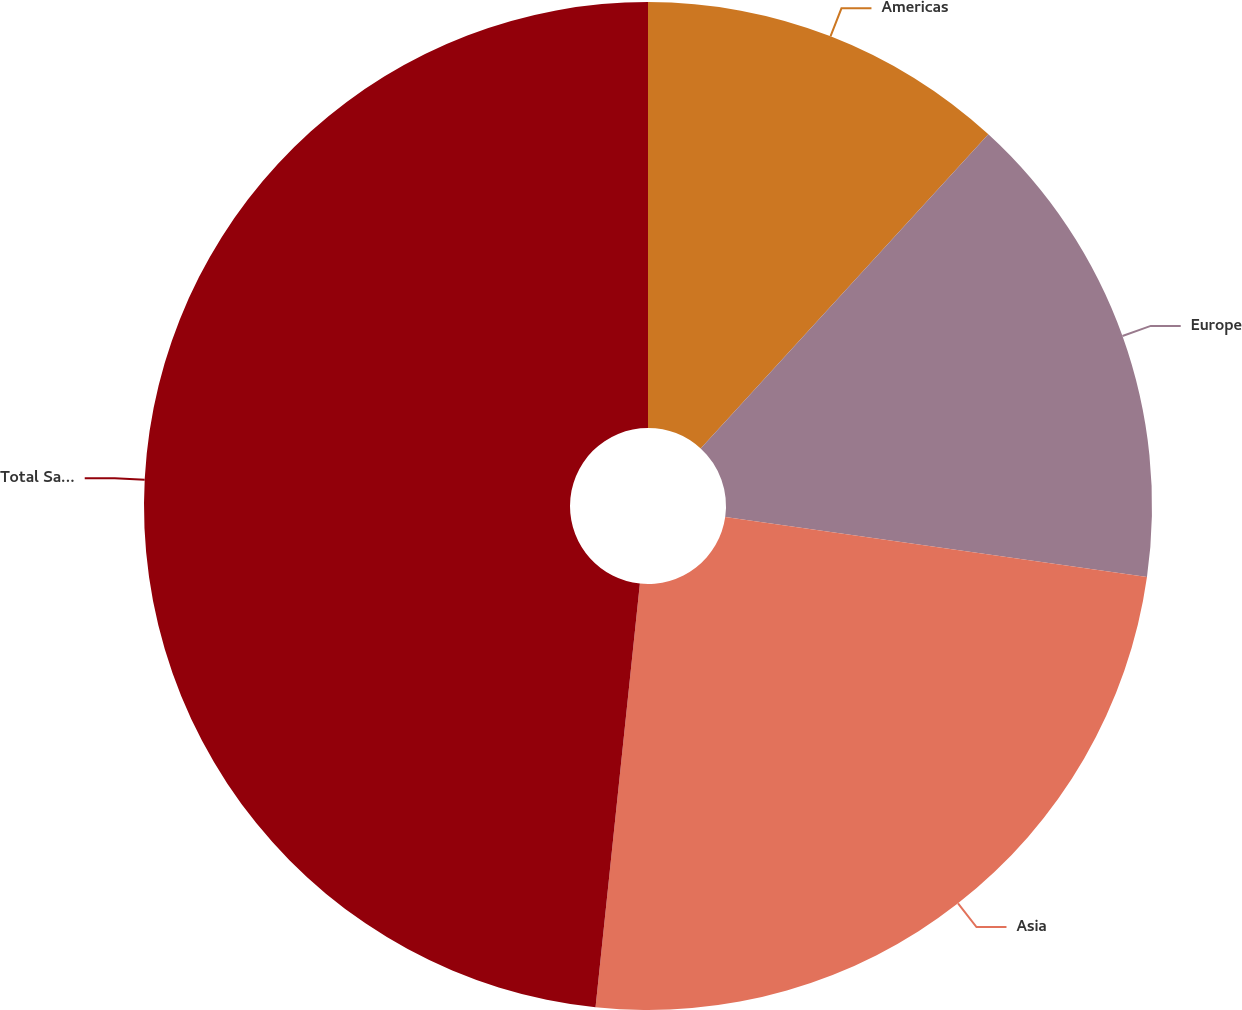Convert chart. <chart><loc_0><loc_0><loc_500><loc_500><pie_chart><fcel>Americas<fcel>Europe<fcel>Asia<fcel>Total Sales<nl><fcel>11.8%<fcel>15.45%<fcel>24.41%<fcel>48.34%<nl></chart> 